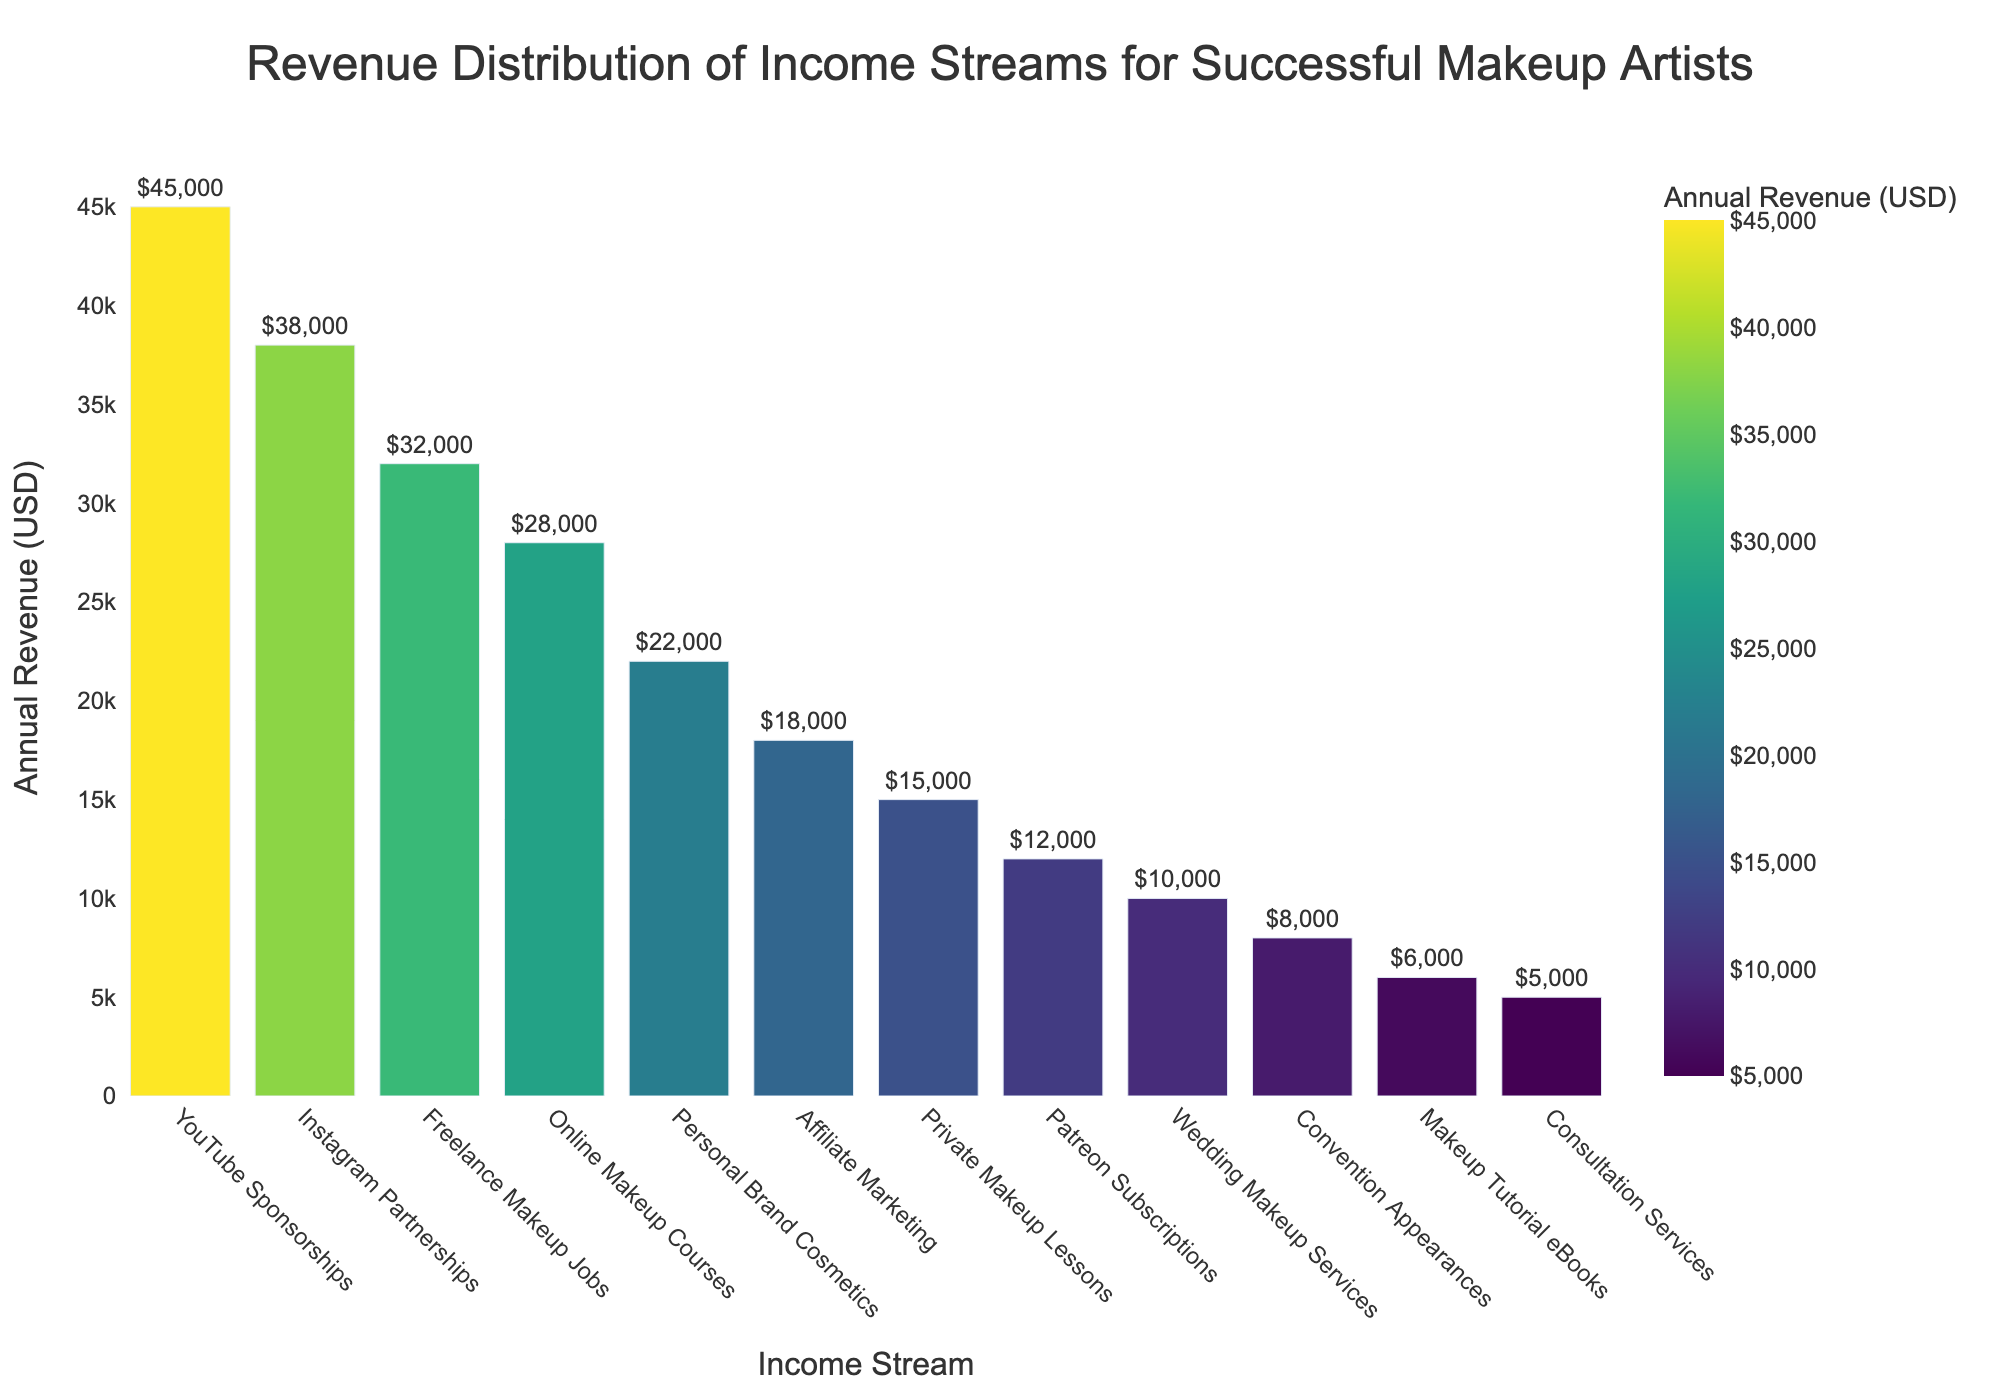What is the highest annual revenue stream? The highest annual revenue stream can be identified by looking for the tallest bar in the chart. It is the bar labeled 'YouTube Sponsorships', which corresponds to an annual revenue of $45,000.
Answer: YouTube Sponsorships Which income stream has the lowest annual revenue? The lowest annual revenue stream can be observed by finding the shortest bar in the chart. It is the bar labeled 'Consultation Services', which corresponds to an annual revenue of $5,000.
Answer: Consultation Services What is the total combined revenue of Instagram Partnerships and Freelance Makeup Jobs? To find the total combined revenue, locate the bars for Instagram Partnerships and Freelance Makeup Jobs. They correspond to $38,000 and $32,000, respectively. Add these values: $38,000 + $32,000 = $70,000.
Answer: $70,000 How much more revenue does YouTube Sponsorships generate compared to Personal Brand Cosmetics? First, find the revenue for both income streams: YouTube Sponsorships ($45,000) and Personal Brand Cosmetics ($22,000). Subtract the latter from the former: $45,000 - $22,000 = $23,000.
Answer: $23,000 Which income stream generates more revenue: Online Makeup Courses or Private Makeup Lessons? Compare the heights of the bars for Online Makeup Courses and Private Makeup Lessons. The bar for Online Makeup Courses is higher, corresponding to $28,000, while Private Makeup Lessons corresponds to $15,000. Therefore, Online Makeup Courses generate more revenue.
Answer: Online Makeup Courses Is the revenue from Patreon Subscriptions higher or lower than Wedding Makeup Services? Compare the bars for Patreon Subscriptions and Wedding Makeup Services. The bar for Patreon Subscriptions is taller, corresponding to $12,000, while Wedding Makeup Services corresponds to $10,000. Thus, Patreon Subscriptions have higher revenue.
Answer: Higher What is the average annual revenue of the top three income streams? Identify the top three income streams by looking at the tallest bars: YouTube Sponsorships ($45,000), Instagram Partnerships ($38,000), and Freelance Makeup Jobs ($32,000). Calculate the average: ($45,000 + $38,000 + $32,000) / 3 = $38,333.33.
Answer: $38,333.33 Are there more income streams generating above $20,000 annually or below $20,000 annually? Count the income streams above and below $20,000 by observing the heights and labels of the bars. Above $20,000: 5 (YouTube Sponsorships, Instagram Partnerships, Freelance Makeup Jobs, Online Makeup Courses, Personal Brand Cosmetics). Below $20,000: 7 (Affiliate Marketing, Private Makeup Lessons, Patreon Subscriptions, Wedding Makeup Services, Convention Appearances, Makeup Tutorial eBooks, Consultation Services). Therefore, more income streams are below $20,000.
Answer: Below $20,000 How much total revenue do all the streams generate? Sum the revenue values for each income stream: $45,000 + $38,000 + $32,000 + $28,000 + $22,000 + $18,000 + $15,000 + $12,000 + $10,000 + $8,000 + $6,000 + $5,000 = $239,000.
Answer: $239,000 Which income stream's revenue is closest to $20,000? Scan the bars to find which one is nearest to the $20,000 mark. The revenue for Personal Brand Cosmetics is $22,000, which is closest to $20,000.
Answer: Personal Brand Cosmetics 